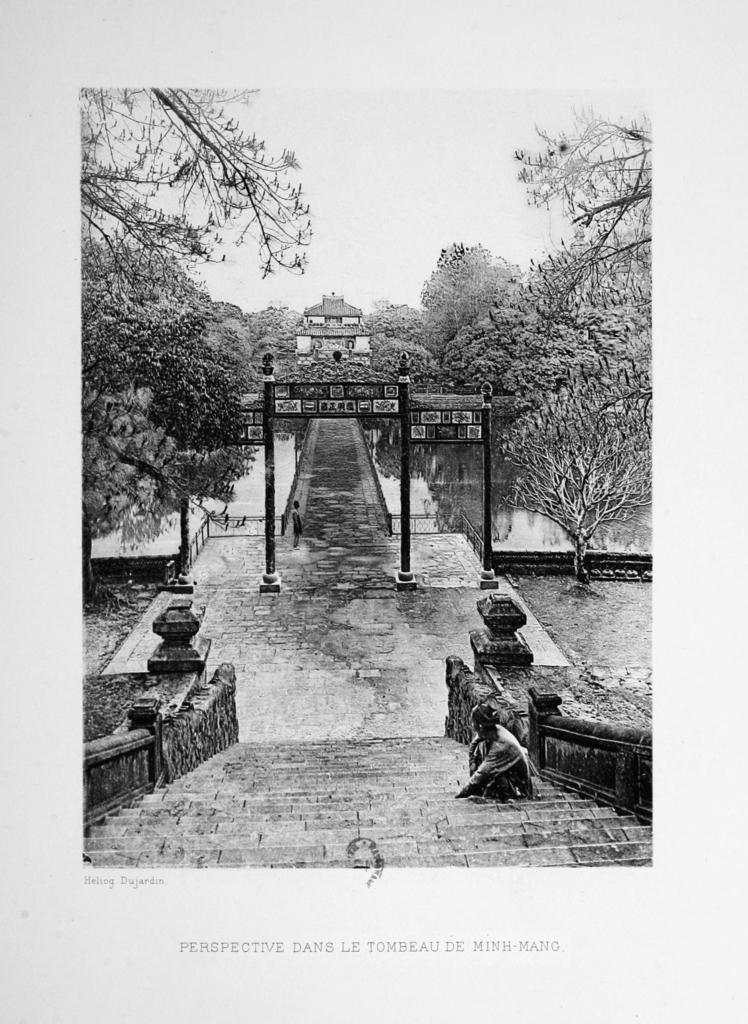What is the color scheme of the image? The image is black and white. Can you describe the main subject in the image? There is a person in the image. What other objects can be seen in the image? There are poles, boards, trees, and water in the image. What is visible in the background of the image? The sky is visible in the background of the image. What type of oatmeal is being served in the image? There is no oatmeal present in the image. Can you describe the frog's behavior in the image? There is no frog present in the image. 